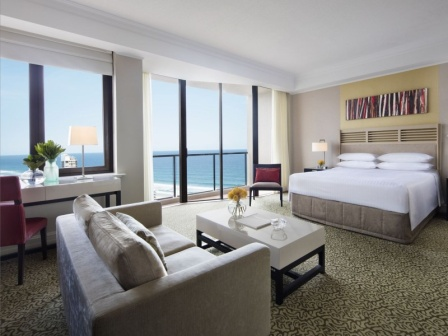Can you describe the main features of this image for me? The image captures a spacious hotel room that exudes a sense of tranquility and comfort. Dominating the room is a large window that frames a serene view of the ocean, extending to a balcony that invites one to soak in the vista. 

Against the right wall, a bed dressed in crisp white linens stands out against a gray headboard. Above the bed, a colorful abstract painting adds a splash of vibrancy to the otherwise neutral palette of the room. 

In the center of the room, a gray sofa is paired with a white coffee table, providing a cozy spot for relaxation or conversation. To the left, a red armchair, accompanied by a white side table and a lamp, offers another inviting nook for rest or reading. 

The floor beneath is carpeted in a striking black and white pattern, adding a touch of sophistication to the room's decor. The careful arrangement of furniture and the thoughtful color scheme create a harmonious space that is both stylish and welcoming. 